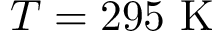<formula> <loc_0><loc_0><loc_500><loc_500>T = 2 9 5 K</formula> 